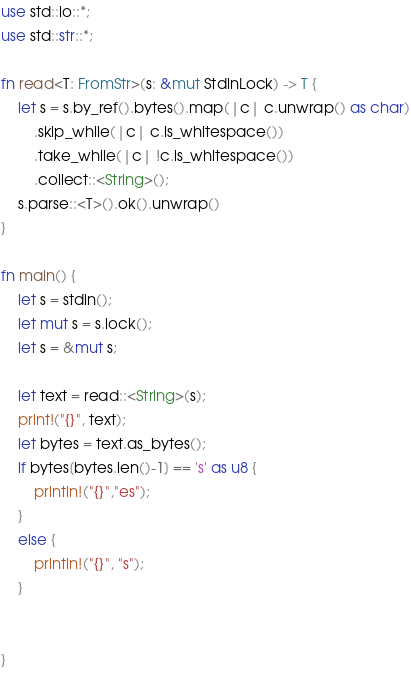<code> <loc_0><loc_0><loc_500><loc_500><_Rust_>use std::io::*;
use std::str::*;

fn read<T: FromStr>(s: &mut StdinLock) -> T {
    let s = s.by_ref().bytes().map(|c| c.unwrap() as char)
        .skip_while(|c| c.is_whitespace())
        .take_while(|c| !c.is_whitespace())
        .collect::<String>();
    s.parse::<T>().ok().unwrap()
}

fn main() {
    let s = stdin();
    let mut s = s.lock();
    let s = &mut s;

	let text = read::<String>(s);
	print!("{}", text);
	let bytes = text.as_bytes();
	if bytes[bytes.len()-1] == 's' as u8 {
		println!("{}","es");
	}
	else { 
		println!("{}", "s");
	}

	
}

</code> 